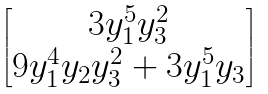<formula> <loc_0><loc_0><loc_500><loc_500>\begin{bmatrix} 3 y _ { 1 } ^ { 5 } y _ { 3 } ^ { 2 } \\ 9 y _ { 1 } ^ { 4 } y _ { 2 } y _ { 3 } ^ { 2 } + 3 y _ { 1 } ^ { 5 } y _ { 3 } \end{bmatrix}</formula> 